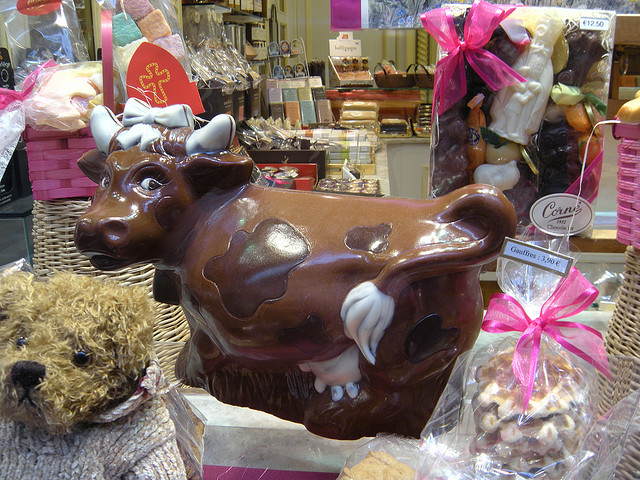Identify the text displayed in this image. Corns C1260 